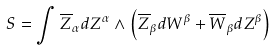<formula> <loc_0><loc_0><loc_500><loc_500>S = \int \overline { Z } _ { \alpha } d Z ^ { \alpha } \wedge \left ( \overline { Z } _ { \beta } d W ^ { \beta } + \overline { W } _ { \beta } d Z ^ { \beta } \right )</formula> 